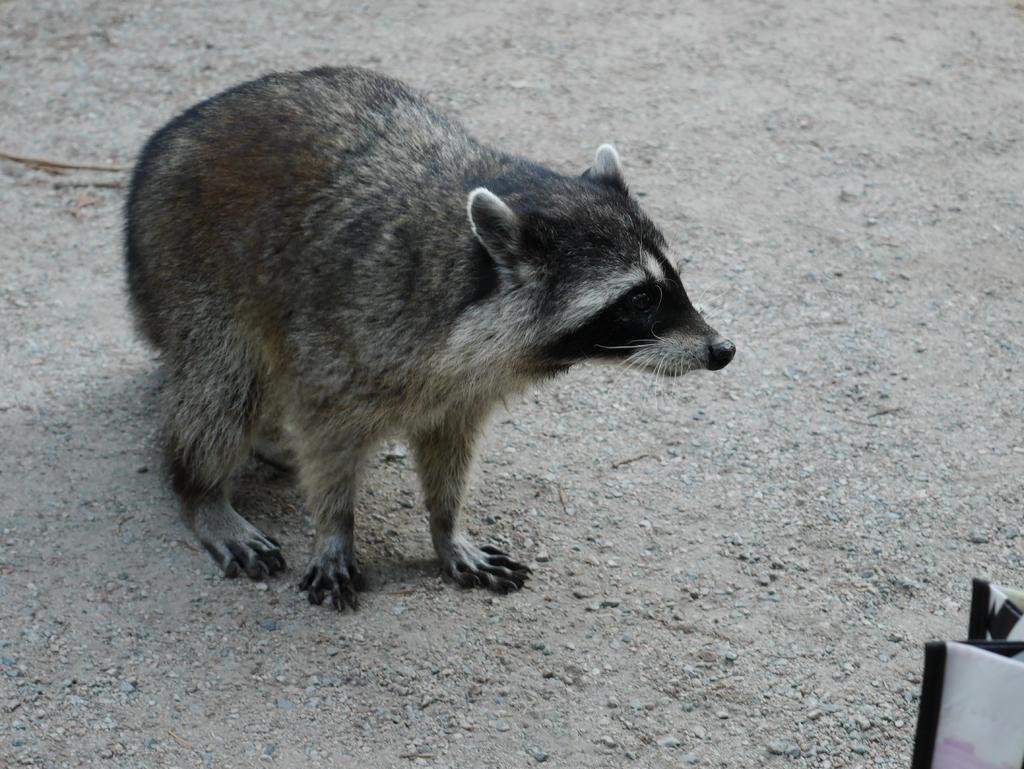Please provide a concise description of this image. In this image I can see a grey colour racoon on ground. Here I can see a white colour thing. 